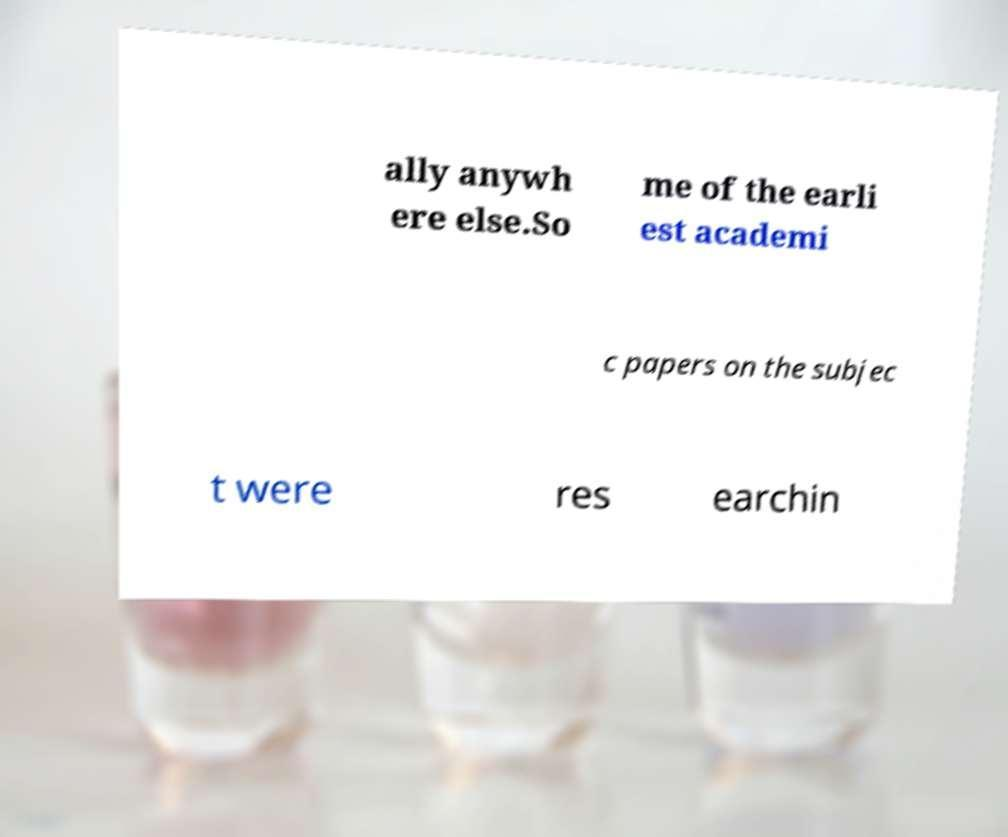What messages or text are displayed in this image? I need them in a readable, typed format. ally anywh ere else.So me of the earli est academi c papers on the subjec t were res earchin 